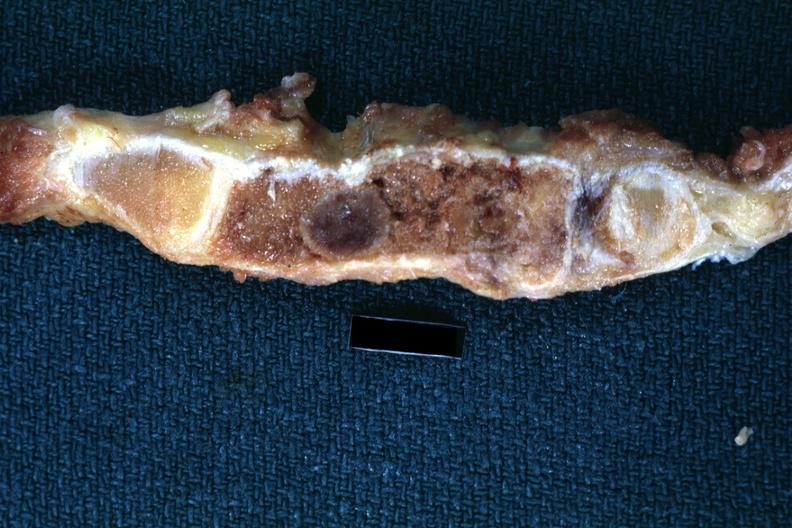what shown close-up very good?
Answer the question using a single word or phrase. Saggital section sternum with typical plasmacytoma 